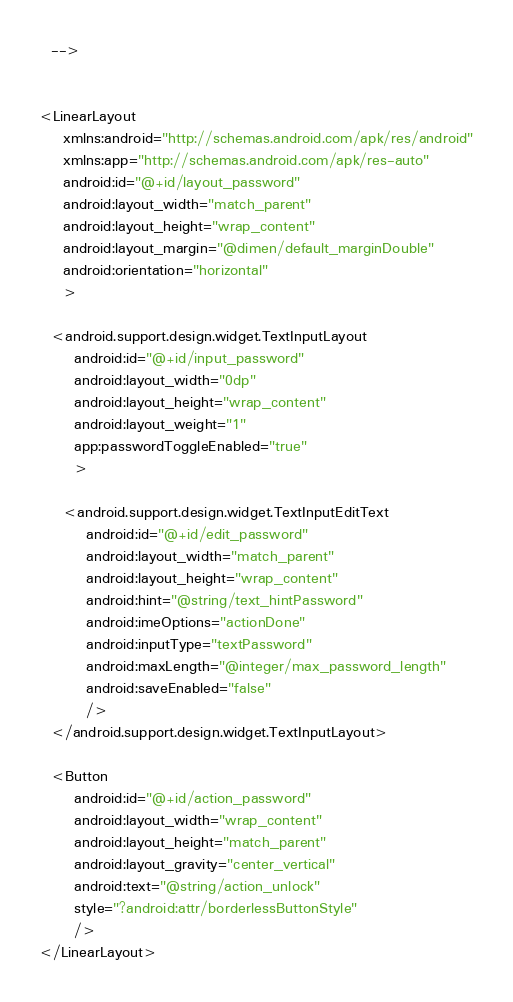<code> <loc_0><loc_0><loc_500><loc_500><_XML_>  -->


<LinearLayout
    xmlns:android="http://schemas.android.com/apk/res/android"
    xmlns:app="http://schemas.android.com/apk/res-auto"
    android:id="@+id/layout_password"
    android:layout_width="match_parent"
    android:layout_height="wrap_content"
    android:layout_margin="@dimen/default_marginDouble"
    android:orientation="horizontal"
    >

  <android.support.design.widget.TextInputLayout
      android:id="@+id/input_password"
      android:layout_width="0dp"
      android:layout_height="wrap_content"
      android:layout_weight="1"
      app:passwordToggleEnabled="true"
      >

    <android.support.design.widget.TextInputEditText
        android:id="@+id/edit_password"
        android:layout_width="match_parent"
        android:layout_height="wrap_content"
        android:hint="@string/text_hintPassword"
        android:imeOptions="actionDone"
        android:inputType="textPassword"
        android:maxLength="@integer/max_password_length"
        android:saveEnabled="false"
        />
  </android.support.design.widget.TextInputLayout>

  <Button
      android:id="@+id/action_password"
      android:layout_width="wrap_content"
      android:layout_height="match_parent"
      android:layout_gravity="center_vertical"
      android:text="@string/action_unlock"
      style="?android:attr/borderlessButtonStyle"
      />
</LinearLayout></code> 